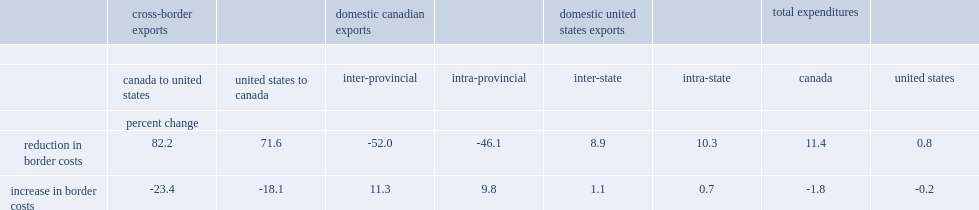What is a reduction increases trade from canada to the united states by? 82.2. What is a reduction increases trade from the united states to canada by? 71.6. What was the percent of welfare (total expenditures on domestic and imported goods) increases in canada? 11.4. What was the percent of welfare (total expenditures on domestic and imported goods) increases in the united states? 0.8. How many percent does an increase in border costs reduce trade from canada to the united states? 23.4. How many percent does an increase in border costs reduce trade from united states to canada? 18.1. How many percent does a substitution towards internal trade in canada rises by? 9.8. How many percent dose domestic trade in the united states rise by? 1.1. How many percent does overall welfare decline by in canada? 1.8. How many percent does overall welfare decline by in the united states? -0.2. 